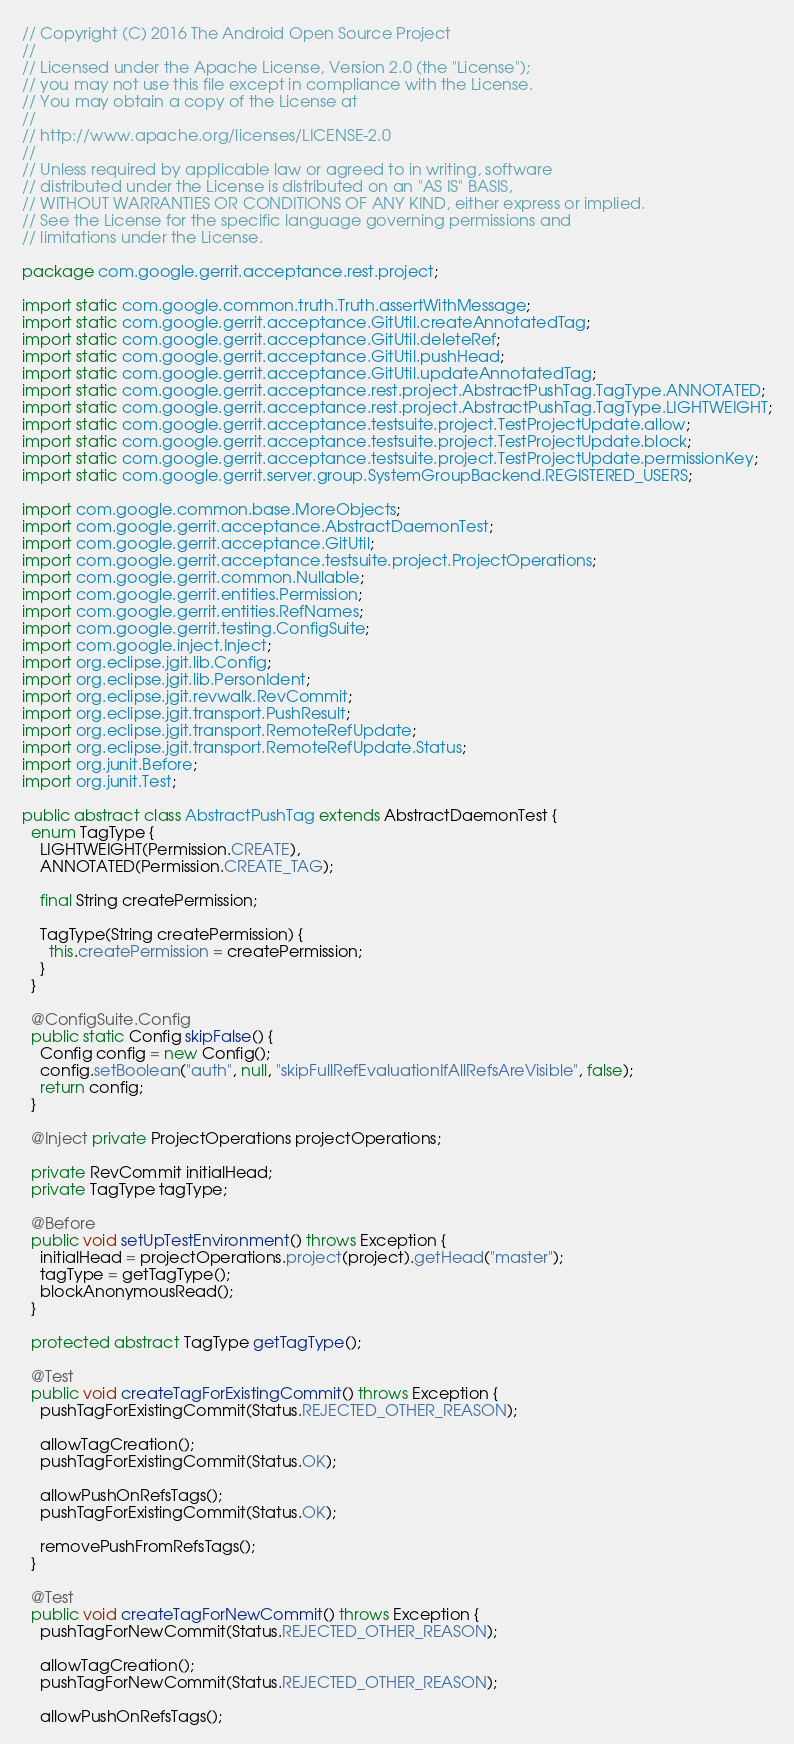<code> <loc_0><loc_0><loc_500><loc_500><_Java_>// Copyright (C) 2016 The Android Open Source Project
//
// Licensed under the Apache License, Version 2.0 (the "License");
// you may not use this file except in compliance with the License.
// You may obtain a copy of the License at
//
// http://www.apache.org/licenses/LICENSE-2.0
//
// Unless required by applicable law or agreed to in writing, software
// distributed under the License is distributed on an "AS IS" BASIS,
// WITHOUT WARRANTIES OR CONDITIONS OF ANY KIND, either express or implied.
// See the License for the specific language governing permissions and
// limitations under the License.

package com.google.gerrit.acceptance.rest.project;

import static com.google.common.truth.Truth.assertWithMessage;
import static com.google.gerrit.acceptance.GitUtil.createAnnotatedTag;
import static com.google.gerrit.acceptance.GitUtil.deleteRef;
import static com.google.gerrit.acceptance.GitUtil.pushHead;
import static com.google.gerrit.acceptance.GitUtil.updateAnnotatedTag;
import static com.google.gerrit.acceptance.rest.project.AbstractPushTag.TagType.ANNOTATED;
import static com.google.gerrit.acceptance.rest.project.AbstractPushTag.TagType.LIGHTWEIGHT;
import static com.google.gerrit.acceptance.testsuite.project.TestProjectUpdate.allow;
import static com.google.gerrit.acceptance.testsuite.project.TestProjectUpdate.block;
import static com.google.gerrit.acceptance.testsuite.project.TestProjectUpdate.permissionKey;
import static com.google.gerrit.server.group.SystemGroupBackend.REGISTERED_USERS;

import com.google.common.base.MoreObjects;
import com.google.gerrit.acceptance.AbstractDaemonTest;
import com.google.gerrit.acceptance.GitUtil;
import com.google.gerrit.acceptance.testsuite.project.ProjectOperations;
import com.google.gerrit.common.Nullable;
import com.google.gerrit.entities.Permission;
import com.google.gerrit.entities.RefNames;
import com.google.gerrit.testing.ConfigSuite;
import com.google.inject.Inject;
import org.eclipse.jgit.lib.Config;
import org.eclipse.jgit.lib.PersonIdent;
import org.eclipse.jgit.revwalk.RevCommit;
import org.eclipse.jgit.transport.PushResult;
import org.eclipse.jgit.transport.RemoteRefUpdate;
import org.eclipse.jgit.transport.RemoteRefUpdate.Status;
import org.junit.Before;
import org.junit.Test;

public abstract class AbstractPushTag extends AbstractDaemonTest {
  enum TagType {
    LIGHTWEIGHT(Permission.CREATE),
    ANNOTATED(Permission.CREATE_TAG);

    final String createPermission;

    TagType(String createPermission) {
      this.createPermission = createPermission;
    }
  }

  @ConfigSuite.Config
  public static Config skipFalse() {
    Config config = new Config();
    config.setBoolean("auth", null, "skipFullRefEvaluationIfAllRefsAreVisible", false);
    return config;
  }

  @Inject private ProjectOperations projectOperations;

  private RevCommit initialHead;
  private TagType tagType;

  @Before
  public void setUpTestEnvironment() throws Exception {
    initialHead = projectOperations.project(project).getHead("master");
    tagType = getTagType();
    blockAnonymousRead();
  }

  protected abstract TagType getTagType();

  @Test
  public void createTagForExistingCommit() throws Exception {
    pushTagForExistingCommit(Status.REJECTED_OTHER_REASON);

    allowTagCreation();
    pushTagForExistingCommit(Status.OK);

    allowPushOnRefsTags();
    pushTagForExistingCommit(Status.OK);

    removePushFromRefsTags();
  }

  @Test
  public void createTagForNewCommit() throws Exception {
    pushTagForNewCommit(Status.REJECTED_OTHER_REASON);

    allowTagCreation();
    pushTagForNewCommit(Status.REJECTED_OTHER_REASON);

    allowPushOnRefsTags();</code> 